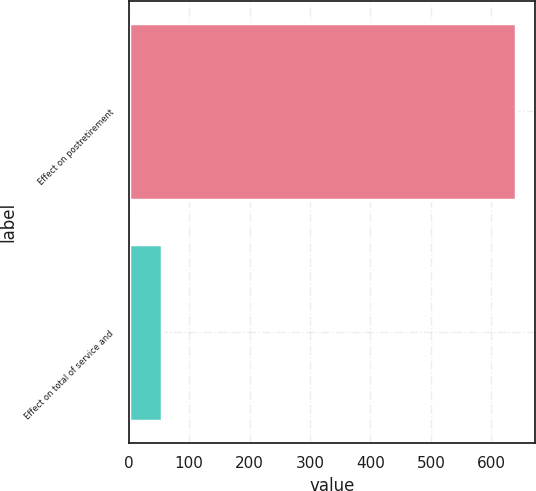<chart> <loc_0><loc_0><loc_500><loc_500><bar_chart><fcel>Effect on postretirement<fcel>Effect on total of service and<nl><fcel>640<fcel>56<nl></chart> 